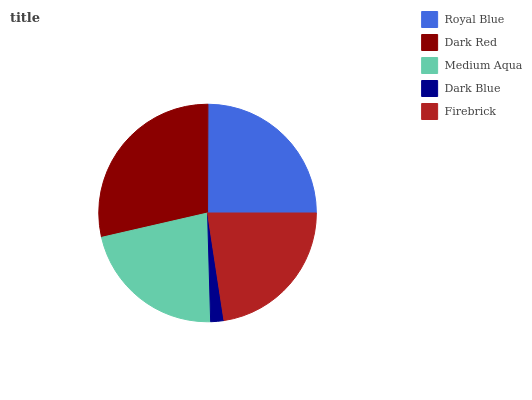Is Dark Blue the minimum?
Answer yes or no. Yes. Is Dark Red the maximum?
Answer yes or no. Yes. Is Medium Aqua the minimum?
Answer yes or no. No. Is Medium Aqua the maximum?
Answer yes or no. No. Is Dark Red greater than Medium Aqua?
Answer yes or no. Yes. Is Medium Aqua less than Dark Red?
Answer yes or no. Yes. Is Medium Aqua greater than Dark Red?
Answer yes or no. No. Is Dark Red less than Medium Aqua?
Answer yes or no. No. Is Firebrick the high median?
Answer yes or no. Yes. Is Firebrick the low median?
Answer yes or no. Yes. Is Dark Blue the high median?
Answer yes or no. No. Is Royal Blue the low median?
Answer yes or no. No. 